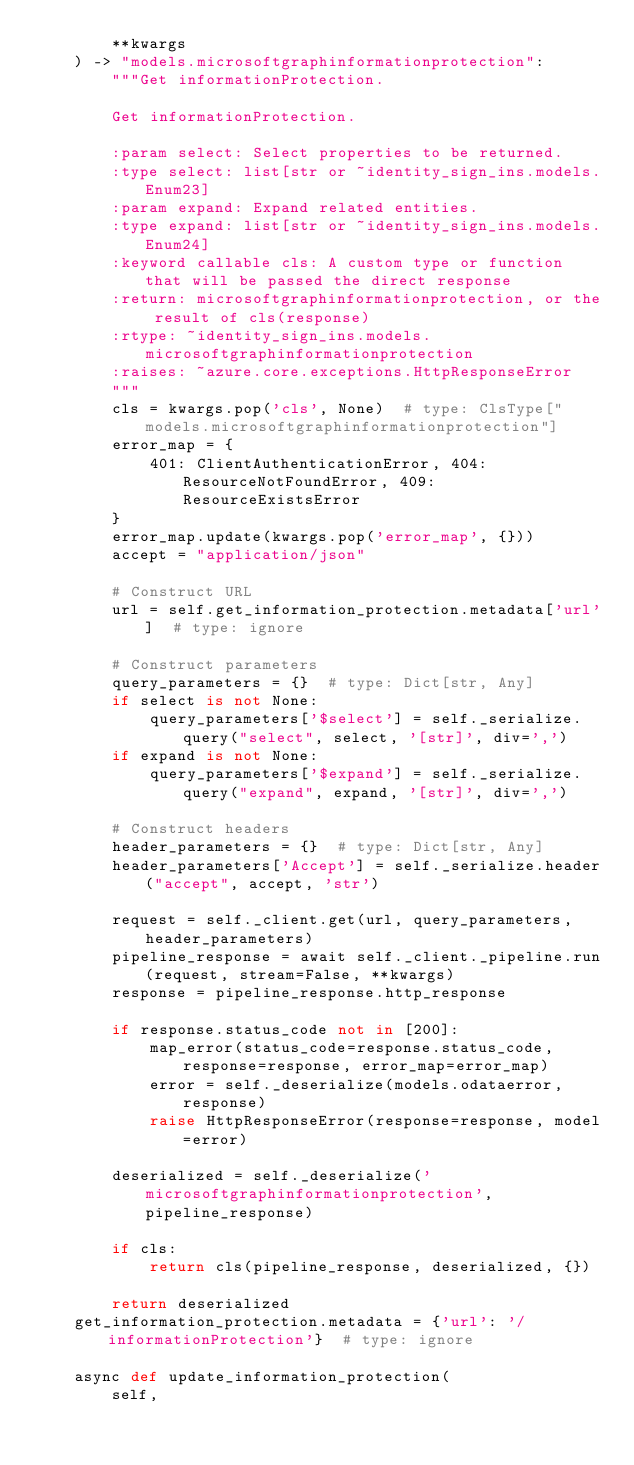<code> <loc_0><loc_0><loc_500><loc_500><_Python_>        **kwargs
    ) -> "models.microsoftgraphinformationprotection":
        """Get informationProtection.

        Get informationProtection.

        :param select: Select properties to be returned.
        :type select: list[str or ~identity_sign_ins.models.Enum23]
        :param expand: Expand related entities.
        :type expand: list[str or ~identity_sign_ins.models.Enum24]
        :keyword callable cls: A custom type or function that will be passed the direct response
        :return: microsoftgraphinformationprotection, or the result of cls(response)
        :rtype: ~identity_sign_ins.models.microsoftgraphinformationprotection
        :raises: ~azure.core.exceptions.HttpResponseError
        """
        cls = kwargs.pop('cls', None)  # type: ClsType["models.microsoftgraphinformationprotection"]
        error_map = {
            401: ClientAuthenticationError, 404: ResourceNotFoundError, 409: ResourceExistsError
        }
        error_map.update(kwargs.pop('error_map', {}))
        accept = "application/json"

        # Construct URL
        url = self.get_information_protection.metadata['url']  # type: ignore

        # Construct parameters
        query_parameters = {}  # type: Dict[str, Any]
        if select is not None:
            query_parameters['$select'] = self._serialize.query("select", select, '[str]', div=',')
        if expand is not None:
            query_parameters['$expand'] = self._serialize.query("expand", expand, '[str]', div=',')

        # Construct headers
        header_parameters = {}  # type: Dict[str, Any]
        header_parameters['Accept'] = self._serialize.header("accept", accept, 'str')

        request = self._client.get(url, query_parameters, header_parameters)
        pipeline_response = await self._client._pipeline.run(request, stream=False, **kwargs)
        response = pipeline_response.http_response

        if response.status_code not in [200]:
            map_error(status_code=response.status_code, response=response, error_map=error_map)
            error = self._deserialize(models.odataerror, response)
            raise HttpResponseError(response=response, model=error)

        deserialized = self._deserialize('microsoftgraphinformationprotection', pipeline_response)

        if cls:
            return cls(pipeline_response, deserialized, {})

        return deserialized
    get_information_protection.metadata = {'url': '/informationProtection'}  # type: ignore

    async def update_information_protection(
        self,</code> 